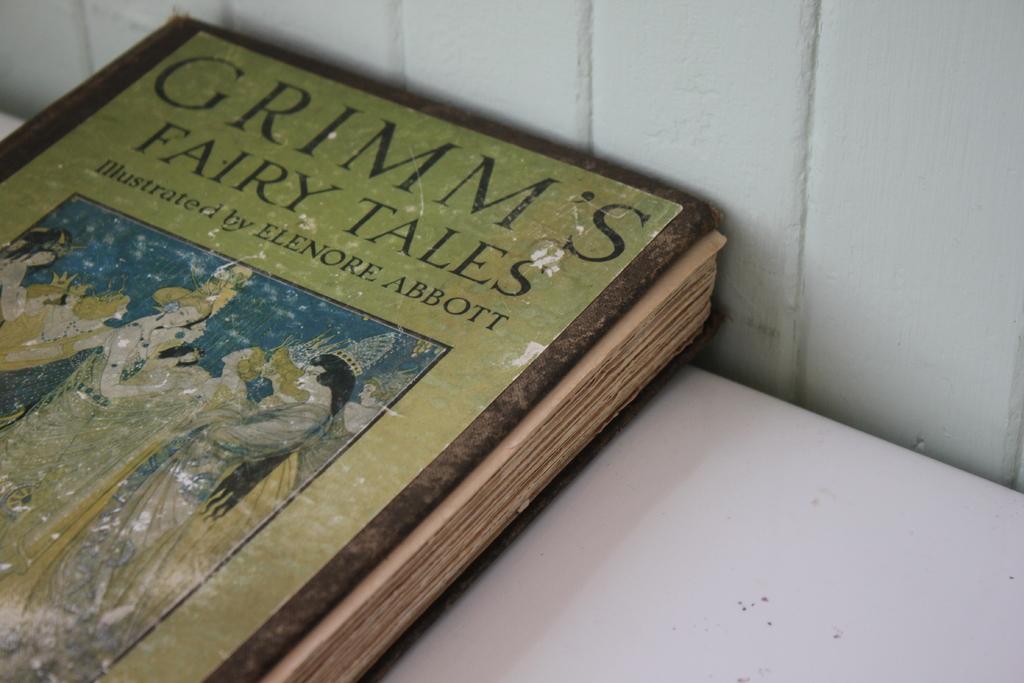Who illustrated this book?
Make the answer very short. Elenore abbott. What is the title of the book?
Offer a very short reply. Grimm's fairy tales. 